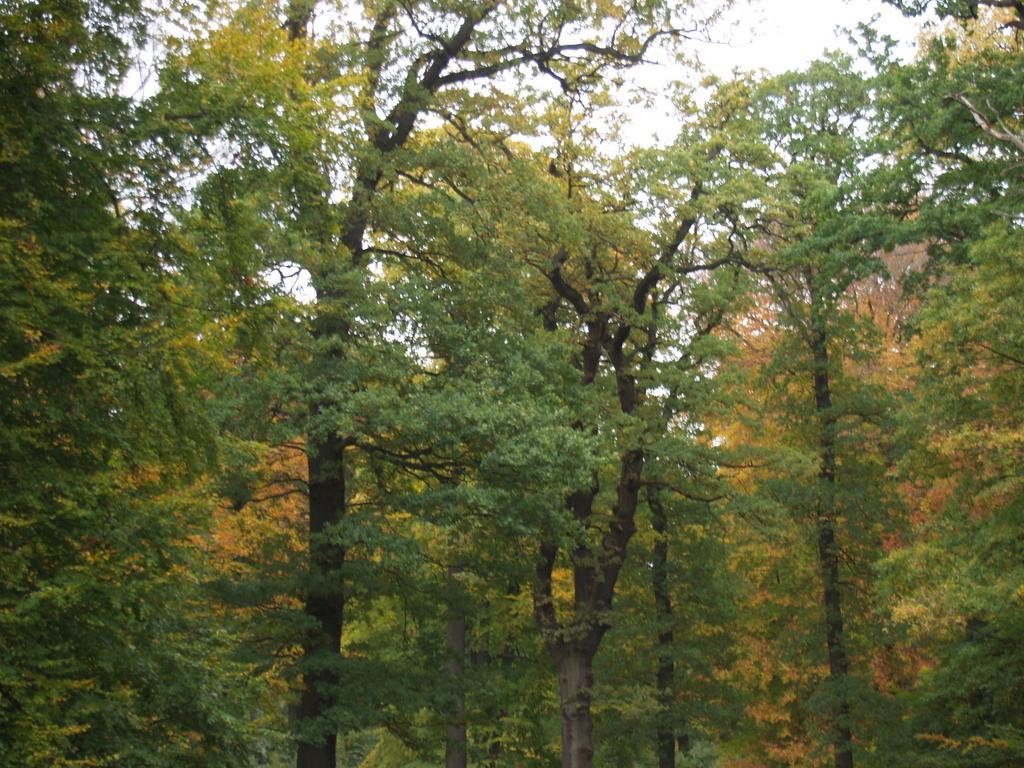Please provide a concise description of this image. In this picture we can see there are trees and the sky. 